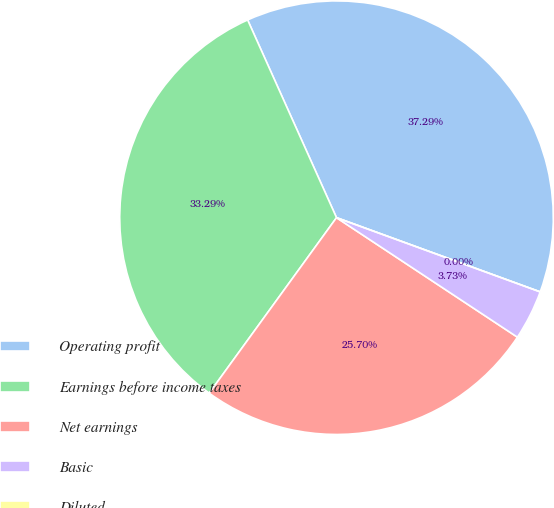Convert chart to OTSL. <chart><loc_0><loc_0><loc_500><loc_500><pie_chart><fcel>Operating profit<fcel>Earnings before income taxes<fcel>Net earnings<fcel>Basic<fcel>Diluted<nl><fcel>37.29%<fcel>33.29%<fcel>25.7%<fcel>3.73%<fcel>0.0%<nl></chart> 